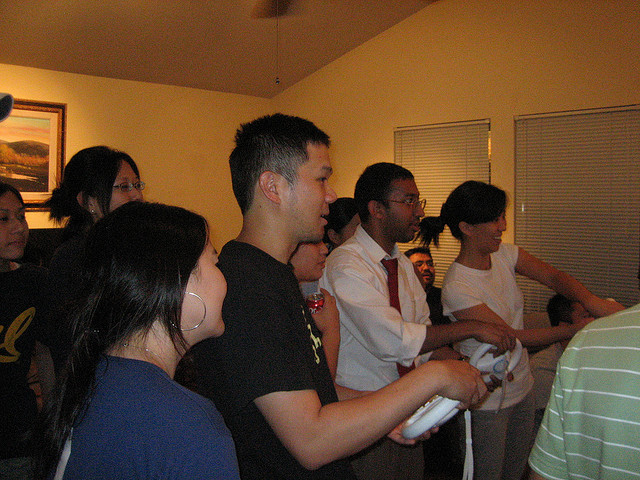<image>What game are these people playing? I'm not certain what game these people are playing. It could be 'wii' or 'mario kart'. What game are these people playing? I am not sure what game these people are playing. It can be either 'Wii', 'Mario Kart' or some other unknown driving game. 